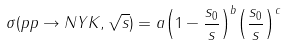<formula> <loc_0><loc_0><loc_500><loc_500>\sigma ( p p \to N Y K , \sqrt { s } ) = a { \left ( 1 - \frac { s _ { 0 } } { s } \right ) } ^ { b } { \left ( \frac { s _ { 0 } } { s } \right ) } ^ { c }</formula> 